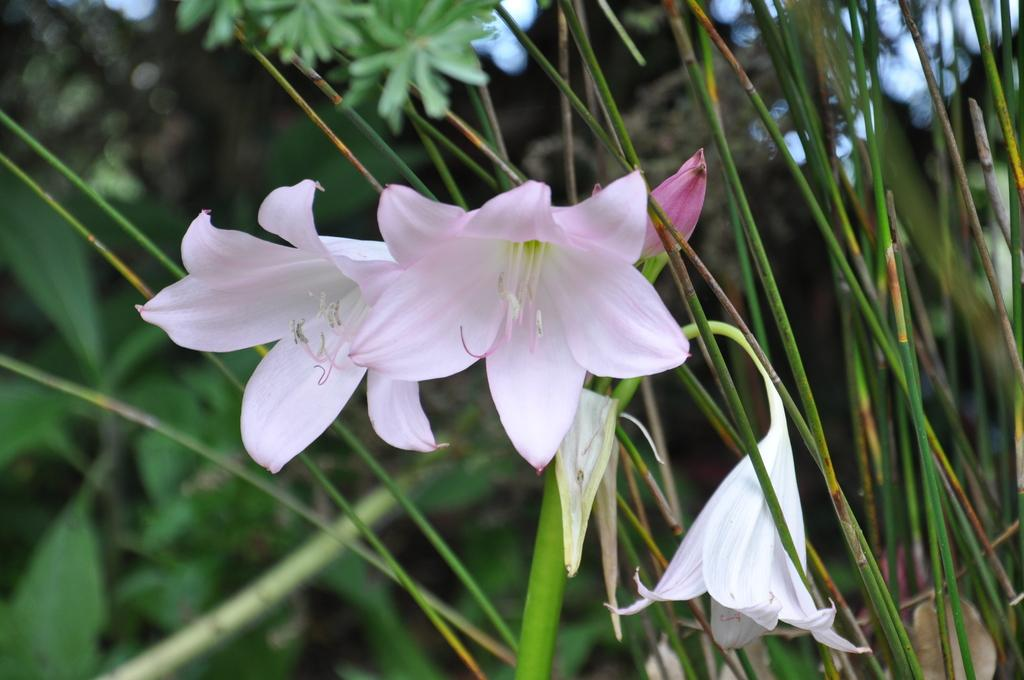What type of plant elements can be seen in the image? There are flowers, leaves, and stems in the image. Can you describe the background of the image? The background of the image is blurred. What type of degree is required to wear the skirt in the image? There is no skirt present in the image, so this question cannot be answered. 